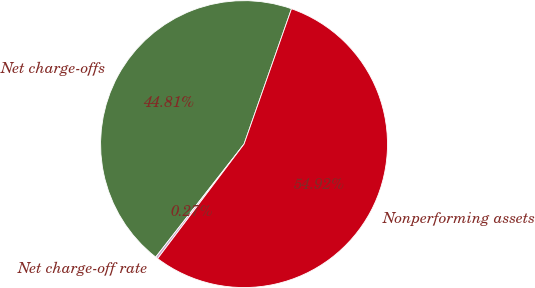<chart> <loc_0><loc_0><loc_500><loc_500><pie_chart><fcel>Net charge-offs<fcel>Net charge-off rate<fcel>Nonperforming assets<nl><fcel>44.81%<fcel>0.27%<fcel>54.92%<nl></chart> 